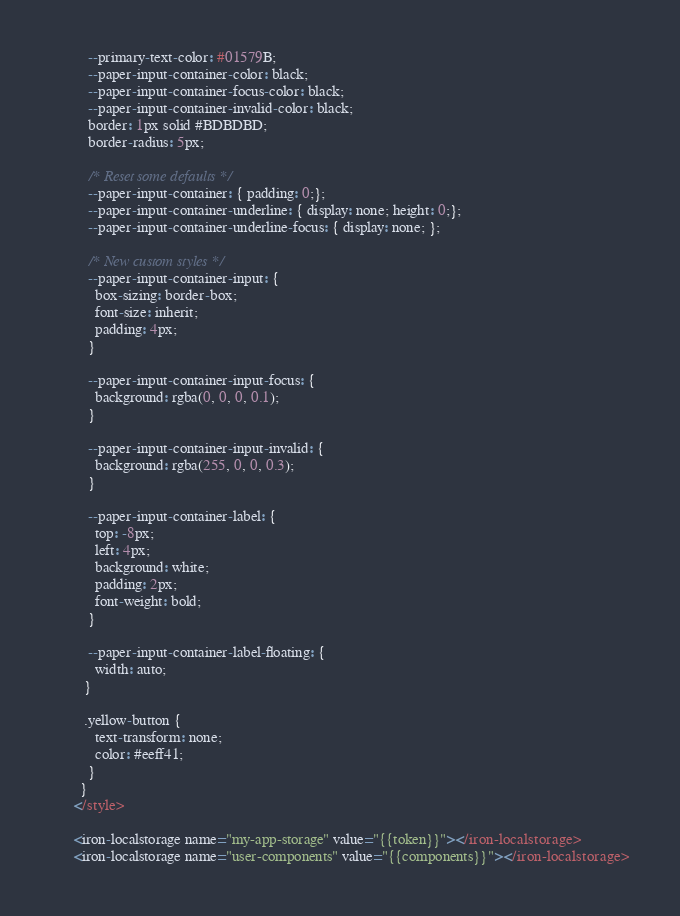Convert code to text. <code><loc_0><loc_0><loc_500><loc_500><_JavaScript_>          --primary-text-color: #01579B;
          --paper-input-container-color: black;
          --paper-input-container-focus-color: black;
          --paper-input-container-invalid-color: black;
          border: 1px solid #BDBDBD;
          border-radius: 5px;

          /* Reset some defaults */
          --paper-input-container: { padding: 0;};
          --paper-input-container-underline: { display: none; height: 0;};
          --paper-input-container-underline-focus: { display: none; };

          /* New custom styles */
          --paper-input-container-input: {
            box-sizing: border-box;
            font-size: inherit;
            padding: 4px;
          }

          --paper-input-container-input-focus: {
            background: rgba(0, 0, 0, 0.1);
          }

          --paper-input-container-input-invalid: {
            background: rgba(255, 0, 0, 0.3);
          }

          --paper-input-container-label: {
            top: -8px;
            left: 4px;
            background: white;
            padding: 2px;
            font-weight: bold;
          }

          --paper-input-container-label-floating: {
            width: auto;
         }

         .yellow-button {
            text-transform: none;
            color: #eeff41;
          }
        }
      </style>

      <iron-localstorage name="my-app-storage" value="{{token}}"></iron-localstorage>
      <iron-localstorage name="user-components" value="{{components}}"></iron-localstorage>
</code> 